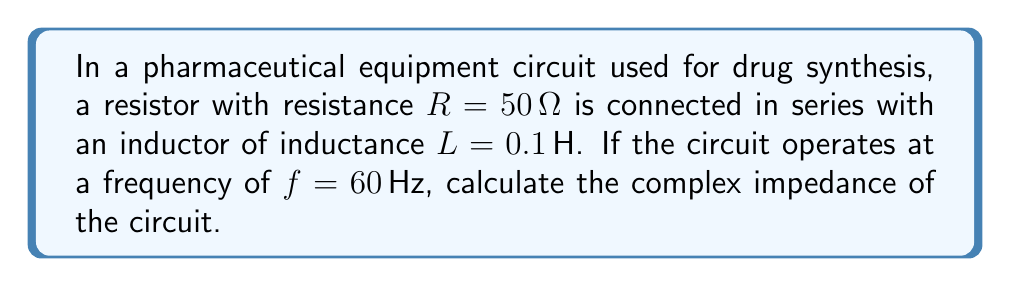Provide a solution to this math problem. To calculate the complex impedance, we follow these steps:

1) The complex impedance $Z$ is given by:
   $$ Z = R + jX_L $$
   where $R$ is the resistance and $X_L$ is the inductive reactance.

2) We already know $R = 50 \Omega$. We need to calculate $X_L$.

3) The inductive reactance $X_L$ is given by:
   $$ X_L = 2\pi fL $$

4) Substituting the values:
   $$ X_L = 2\pi (60 Hz)(0.1 H) = 37.7 \Omega $$

5) Now we can form the complex impedance:
   $$ Z = 50 + j37.7 \Omega $$

6) This can be written in polar form as:
   $$ Z = \sqrt{50^2 + 37.7^2} \angle \tan^{-1}(37.7/50) $$
   $$ Z \approx 62.6 \angle 37.0° \Omega $$
Answer: $Z = 50 + j37.7 \Omega$ or $62.6 \angle 37.0° \Omega$ 